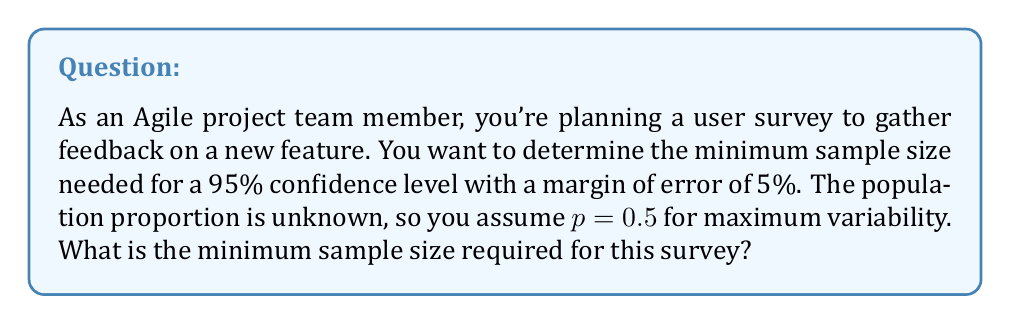Show me your answer to this math problem. To determine the sample size for a user survey with a specified confidence level, we'll use the formula:

$$n = \frac{z^2 \cdot p(1-p)}{E^2}$$

Where:
$n$ = sample size
$z$ = z-score for the desired confidence level
$p$ = population proportion (assumed 0.5 for maximum variability)
$E$ = margin of error

Steps:
1. Identify the given information:
   - Confidence level: 95%
   - Margin of error (E): 5% = 0.05
   - p = 0.5 (assumed for maximum variability)

2. Find the z-score for 95% confidence level:
   The z-score for 95% confidence is 1.96

3. Plug the values into the formula:
   $$n = \frac{(1.96)^2 \cdot 0.5(1-0.5)}{(0.05)^2}$$

4. Calculate:
   $$n = \frac{3.8416 \cdot 0.25}{0.0025} = \frac{0.9604}{0.0025} = 384.16$$

5. Round up to the nearest whole number:
   $n = 385$

This sample size ensures that the survey results will be within ±5% of the true population value with 95% confidence.
Answer: 385 respondents 